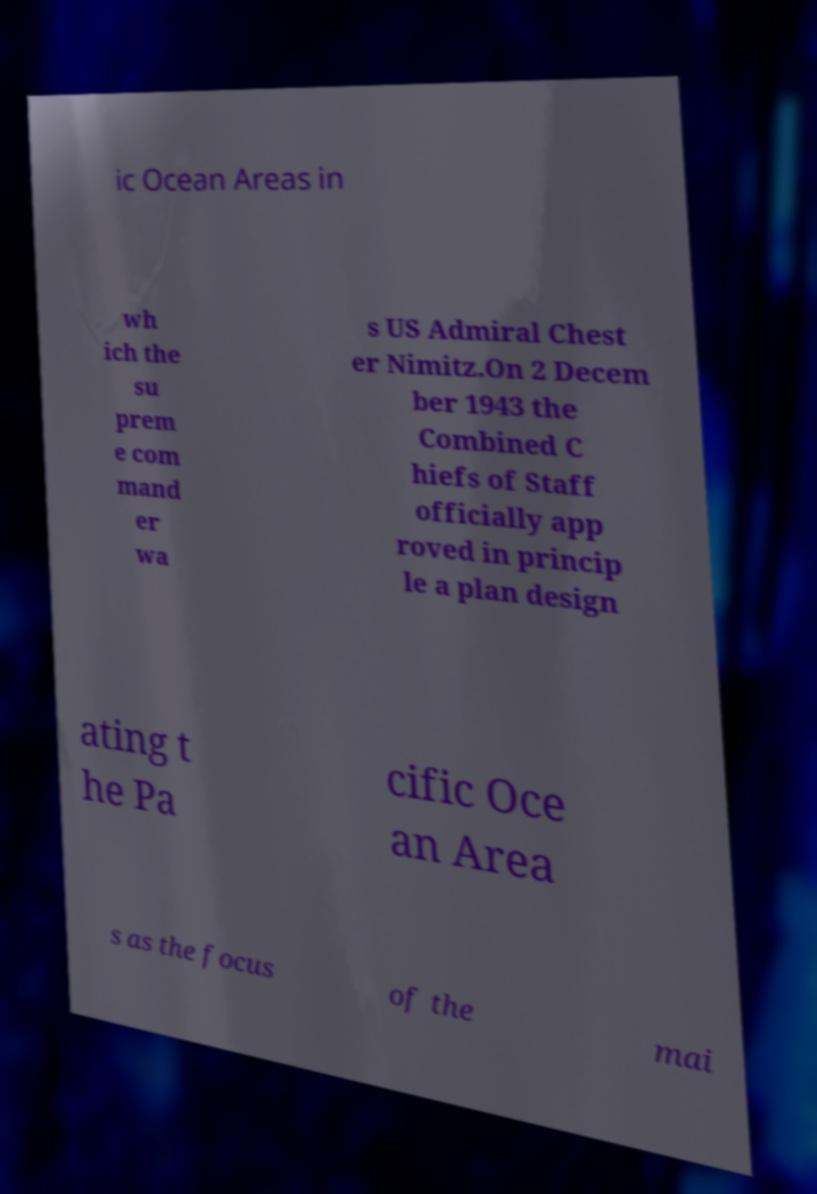Could you extract and type out the text from this image? ic Ocean Areas in wh ich the su prem e com mand er wa s US Admiral Chest er Nimitz.On 2 Decem ber 1943 the Combined C hiefs of Staff officially app roved in princip le a plan design ating t he Pa cific Oce an Area s as the focus of the mai 